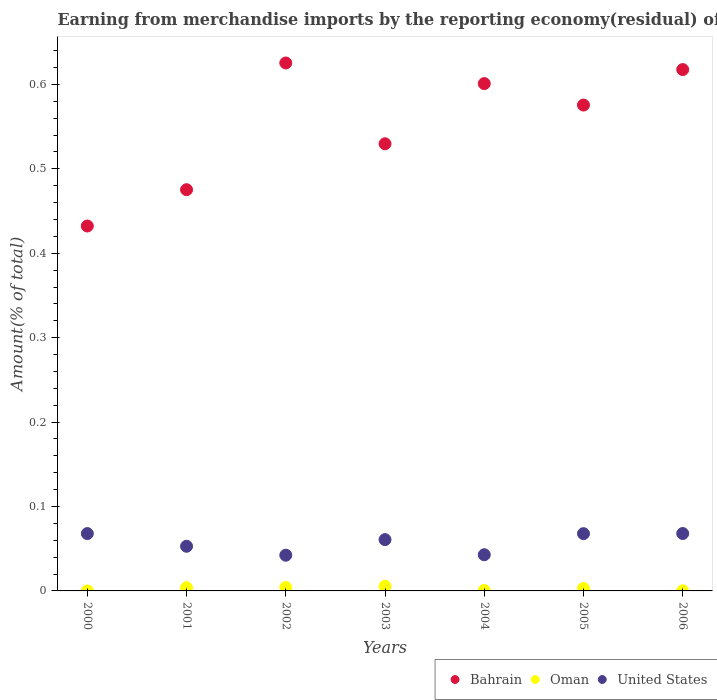How many different coloured dotlines are there?
Make the answer very short. 3. What is the percentage of amount earned from merchandise imports in Bahrain in 2004?
Offer a very short reply. 0.6. Across all years, what is the maximum percentage of amount earned from merchandise imports in United States?
Make the answer very short. 0.07. Across all years, what is the minimum percentage of amount earned from merchandise imports in United States?
Your response must be concise. 0.04. What is the total percentage of amount earned from merchandise imports in United States in the graph?
Your response must be concise. 0.4. What is the difference between the percentage of amount earned from merchandise imports in Bahrain in 2002 and that in 2004?
Give a very brief answer. 0.02. What is the difference between the percentage of amount earned from merchandise imports in Bahrain in 2004 and the percentage of amount earned from merchandise imports in Oman in 2003?
Your answer should be compact. 0.6. What is the average percentage of amount earned from merchandise imports in Oman per year?
Your answer should be compact. 0. In the year 2002, what is the difference between the percentage of amount earned from merchandise imports in Bahrain and percentage of amount earned from merchandise imports in Oman?
Your response must be concise. 0.62. What is the ratio of the percentage of amount earned from merchandise imports in Bahrain in 2003 to that in 2005?
Ensure brevity in your answer.  0.92. Is the difference between the percentage of amount earned from merchandise imports in Bahrain in 2002 and 2006 greater than the difference between the percentage of amount earned from merchandise imports in Oman in 2002 and 2006?
Your response must be concise. Yes. What is the difference between the highest and the second highest percentage of amount earned from merchandise imports in United States?
Your answer should be compact. 6.915576436429538e-5. What is the difference between the highest and the lowest percentage of amount earned from merchandise imports in Oman?
Your answer should be very brief. 0.01. Is the percentage of amount earned from merchandise imports in Oman strictly greater than the percentage of amount earned from merchandise imports in Bahrain over the years?
Your response must be concise. No. Is the percentage of amount earned from merchandise imports in United States strictly less than the percentage of amount earned from merchandise imports in Bahrain over the years?
Ensure brevity in your answer.  Yes. How many dotlines are there?
Your response must be concise. 3. How many years are there in the graph?
Your response must be concise. 7. What is the difference between two consecutive major ticks on the Y-axis?
Offer a very short reply. 0.1. Are the values on the major ticks of Y-axis written in scientific E-notation?
Provide a succinct answer. No. How many legend labels are there?
Your response must be concise. 3. What is the title of the graph?
Ensure brevity in your answer.  Earning from merchandise imports by the reporting economy(residual) of countries. What is the label or title of the Y-axis?
Your answer should be compact. Amount(% of total). What is the Amount(% of total) in Bahrain in 2000?
Make the answer very short. 0.43. What is the Amount(% of total) of United States in 2000?
Keep it short and to the point. 0.07. What is the Amount(% of total) in Bahrain in 2001?
Make the answer very short. 0.48. What is the Amount(% of total) in Oman in 2001?
Provide a short and direct response. 0. What is the Amount(% of total) in United States in 2001?
Your answer should be very brief. 0.05. What is the Amount(% of total) in Bahrain in 2002?
Make the answer very short. 0.63. What is the Amount(% of total) of Oman in 2002?
Offer a very short reply. 0. What is the Amount(% of total) in United States in 2002?
Make the answer very short. 0.04. What is the Amount(% of total) of Bahrain in 2003?
Your answer should be compact. 0.53. What is the Amount(% of total) of Oman in 2003?
Offer a terse response. 0.01. What is the Amount(% of total) of United States in 2003?
Give a very brief answer. 0.06. What is the Amount(% of total) of Bahrain in 2004?
Your response must be concise. 0.6. What is the Amount(% of total) in Oman in 2004?
Offer a very short reply. 0. What is the Amount(% of total) in United States in 2004?
Your answer should be compact. 0.04. What is the Amount(% of total) of Bahrain in 2005?
Provide a succinct answer. 0.58. What is the Amount(% of total) of Oman in 2005?
Your answer should be compact. 0. What is the Amount(% of total) in United States in 2005?
Keep it short and to the point. 0.07. What is the Amount(% of total) in Bahrain in 2006?
Make the answer very short. 0.62. What is the Amount(% of total) of Oman in 2006?
Offer a terse response. 0. What is the Amount(% of total) in United States in 2006?
Offer a terse response. 0.07. Across all years, what is the maximum Amount(% of total) in Bahrain?
Keep it short and to the point. 0.63. Across all years, what is the maximum Amount(% of total) of Oman?
Offer a terse response. 0.01. Across all years, what is the maximum Amount(% of total) of United States?
Give a very brief answer. 0.07. Across all years, what is the minimum Amount(% of total) in Bahrain?
Give a very brief answer. 0.43. Across all years, what is the minimum Amount(% of total) of Oman?
Offer a terse response. 0. Across all years, what is the minimum Amount(% of total) of United States?
Keep it short and to the point. 0.04. What is the total Amount(% of total) in Bahrain in the graph?
Offer a terse response. 3.86. What is the total Amount(% of total) in Oman in the graph?
Your answer should be very brief. 0.02. What is the total Amount(% of total) of United States in the graph?
Provide a succinct answer. 0.4. What is the difference between the Amount(% of total) in Bahrain in 2000 and that in 2001?
Your answer should be compact. -0.04. What is the difference between the Amount(% of total) of United States in 2000 and that in 2001?
Your answer should be compact. 0.01. What is the difference between the Amount(% of total) in Bahrain in 2000 and that in 2002?
Offer a very short reply. -0.19. What is the difference between the Amount(% of total) of United States in 2000 and that in 2002?
Give a very brief answer. 0.03. What is the difference between the Amount(% of total) in Bahrain in 2000 and that in 2003?
Provide a succinct answer. -0.1. What is the difference between the Amount(% of total) in United States in 2000 and that in 2003?
Offer a very short reply. 0.01. What is the difference between the Amount(% of total) of Bahrain in 2000 and that in 2004?
Your answer should be very brief. -0.17. What is the difference between the Amount(% of total) in United States in 2000 and that in 2004?
Make the answer very short. 0.03. What is the difference between the Amount(% of total) in Bahrain in 2000 and that in 2005?
Give a very brief answer. -0.14. What is the difference between the Amount(% of total) in United States in 2000 and that in 2005?
Offer a very short reply. 0. What is the difference between the Amount(% of total) of Bahrain in 2000 and that in 2006?
Make the answer very short. -0.19. What is the difference between the Amount(% of total) in United States in 2000 and that in 2006?
Offer a very short reply. -0. What is the difference between the Amount(% of total) of Bahrain in 2001 and that in 2002?
Give a very brief answer. -0.15. What is the difference between the Amount(% of total) of Oman in 2001 and that in 2002?
Offer a very short reply. -0. What is the difference between the Amount(% of total) in United States in 2001 and that in 2002?
Your answer should be compact. 0.01. What is the difference between the Amount(% of total) of Bahrain in 2001 and that in 2003?
Provide a short and direct response. -0.05. What is the difference between the Amount(% of total) of Oman in 2001 and that in 2003?
Provide a short and direct response. -0. What is the difference between the Amount(% of total) in United States in 2001 and that in 2003?
Ensure brevity in your answer.  -0.01. What is the difference between the Amount(% of total) in Bahrain in 2001 and that in 2004?
Give a very brief answer. -0.13. What is the difference between the Amount(% of total) in Oman in 2001 and that in 2004?
Provide a succinct answer. 0. What is the difference between the Amount(% of total) in Bahrain in 2001 and that in 2005?
Keep it short and to the point. -0.1. What is the difference between the Amount(% of total) in Oman in 2001 and that in 2005?
Give a very brief answer. 0. What is the difference between the Amount(% of total) in United States in 2001 and that in 2005?
Offer a very short reply. -0.01. What is the difference between the Amount(% of total) in Bahrain in 2001 and that in 2006?
Provide a short and direct response. -0.14. What is the difference between the Amount(% of total) of Oman in 2001 and that in 2006?
Provide a succinct answer. 0. What is the difference between the Amount(% of total) in United States in 2001 and that in 2006?
Your answer should be very brief. -0.02. What is the difference between the Amount(% of total) of Bahrain in 2002 and that in 2003?
Offer a very short reply. 0.1. What is the difference between the Amount(% of total) of Oman in 2002 and that in 2003?
Your answer should be very brief. -0. What is the difference between the Amount(% of total) in United States in 2002 and that in 2003?
Give a very brief answer. -0.02. What is the difference between the Amount(% of total) in Bahrain in 2002 and that in 2004?
Your answer should be very brief. 0.02. What is the difference between the Amount(% of total) in Oman in 2002 and that in 2004?
Offer a terse response. 0. What is the difference between the Amount(% of total) of United States in 2002 and that in 2004?
Offer a terse response. -0. What is the difference between the Amount(% of total) in Bahrain in 2002 and that in 2005?
Offer a very short reply. 0.05. What is the difference between the Amount(% of total) in Oman in 2002 and that in 2005?
Your response must be concise. 0. What is the difference between the Amount(% of total) in United States in 2002 and that in 2005?
Your answer should be very brief. -0.03. What is the difference between the Amount(% of total) in Bahrain in 2002 and that in 2006?
Ensure brevity in your answer.  0.01. What is the difference between the Amount(% of total) of Oman in 2002 and that in 2006?
Provide a succinct answer. 0. What is the difference between the Amount(% of total) of United States in 2002 and that in 2006?
Provide a short and direct response. -0.03. What is the difference between the Amount(% of total) of Bahrain in 2003 and that in 2004?
Ensure brevity in your answer.  -0.07. What is the difference between the Amount(% of total) of Oman in 2003 and that in 2004?
Offer a terse response. 0.01. What is the difference between the Amount(% of total) of United States in 2003 and that in 2004?
Your answer should be very brief. 0.02. What is the difference between the Amount(% of total) in Bahrain in 2003 and that in 2005?
Offer a very short reply. -0.05. What is the difference between the Amount(% of total) of Oman in 2003 and that in 2005?
Make the answer very short. 0. What is the difference between the Amount(% of total) in United States in 2003 and that in 2005?
Provide a succinct answer. -0.01. What is the difference between the Amount(% of total) in Bahrain in 2003 and that in 2006?
Provide a short and direct response. -0.09. What is the difference between the Amount(% of total) of Oman in 2003 and that in 2006?
Provide a short and direct response. 0.01. What is the difference between the Amount(% of total) of United States in 2003 and that in 2006?
Your answer should be compact. -0.01. What is the difference between the Amount(% of total) in Bahrain in 2004 and that in 2005?
Your response must be concise. 0.03. What is the difference between the Amount(% of total) of Oman in 2004 and that in 2005?
Offer a terse response. -0. What is the difference between the Amount(% of total) of United States in 2004 and that in 2005?
Your answer should be very brief. -0.03. What is the difference between the Amount(% of total) of Bahrain in 2004 and that in 2006?
Your response must be concise. -0.02. What is the difference between the Amount(% of total) in United States in 2004 and that in 2006?
Your response must be concise. -0.03. What is the difference between the Amount(% of total) of Bahrain in 2005 and that in 2006?
Keep it short and to the point. -0.04. What is the difference between the Amount(% of total) in Oman in 2005 and that in 2006?
Your response must be concise. 0. What is the difference between the Amount(% of total) of United States in 2005 and that in 2006?
Offer a very short reply. -0. What is the difference between the Amount(% of total) in Bahrain in 2000 and the Amount(% of total) in Oman in 2001?
Make the answer very short. 0.43. What is the difference between the Amount(% of total) of Bahrain in 2000 and the Amount(% of total) of United States in 2001?
Provide a short and direct response. 0.38. What is the difference between the Amount(% of total) of Bahrain in 2000 and the Amount(% of total) of Oman in 2002?
Your response must be concise. 0.43. What is the difference between the Amount(% of total) in Bahrain in 2000 and the Amount(% of total) in United States in 2002?
Offer a very short reply. 0.39. What is the difference between the Amount(% of total) of Bahrain in 2000 and the Amount(% of total) of Oman in 2003?
Your answer should be very brief. 0.43. What is the difference between the Amount(% of total) of Bahrain in 2000 and the Amount(% of total) of United States in 2003?
Your response must be concise. 0.37. What is the difference between the Amount(% of total) of Bahrain in 2000 and the Amount(% of total) of Oman in 2004?
Keep it short and to the point. 0.43. What is the difference between the Amount(% of total) in Bahrain in 2000 and the Amount(% of total) in United States in 2004?
Your answer should be compact. 0.39. What is the difference between the Amount(% of total) of Bahrain in 2000 and the Amount(% of total) of Oman in 2005?
Provide a succinct answer. 0.43. What is the difference between the Amount(% of total) in Bahrain in 2000 and the Amount(% of total) in United States in 2005?
Your answer should be compact. 0.36. What is the difference between the Amount(% of total) of Bahrain in 2000 and the Amount(% of total) of Oman in 2006?
Provide a short and direct response. 0.43. What is the difference between the Amount(% of total) of Bahrain in 2000 and the Amount(% of total) of United States in 2006?
Ensure brevity in your answer.  0.36. What is the difference between the Amount(% of total) in Bahrain in 2001 and the Amount(% of total) in Oman in 2002?
Ensure brevity in your answer.  0.47. What is the difference between the Amount(% of total) in Bahrain in 2001 and the Amount(% of total) in United States in 2002?
Provide a short and direct response. 0.43. What is the difference between the Amount(% of total) in Oman in 2001 and the Amount(% of total) in United States in 2002?
Give a very brief answer. -0.04. What is the difference between the Amount(% of total) in Bahrain in 2001 and the Amount(% of total) in Oman in 2003?
Provide a short and direct response. 0.47. What is the difference between the Amount(% of total) of Bahrain in 2001 and the Amount(% of total) of United States in 2003?
Keep it short and to the point. 0.41. What is the difference between the Amount(% of total) in Oman in 2001 and the Amount(% of total) in United States in 2003?
Your answer should be very brief. -0.06. What is the difference between the Amount(% of total) of Bahrain in 2001 and the Amount(% of total) of Oman in 2004?
Your response must be concise. 0.47. What is the difference between the Amount(% of total) of Bahrain in 2001 and the Amount(% of total) of United States in 2004?
Offer a very short reply. 0.43. What is the difference between the Amount(% of total) in Oman in 2001 and the Amount(% of total) in United States in 2004?
Offer a terse response. -0.04. What is the difference between the Amount(% of total) of Bahrain in 2001 and the Amount(% of total) of Oman in 2005?
Your response must be concise. 0.47. What is the difference between the Amount(% of total) of Bahrain in 2001 and the Amount(% of total) of United States in 2005?
Ensure brevity in your answer.  0.41. What is the difference between the Amount(% of total) in Oman in 2001 and the Amount(% of total) in United States in 2005?
Your response must be concise. -0.06. What is the difference between the Amount(% of total) of Bahrain in 2001 and the Amount(% of total) of Oman in 2006?
Your answer should be compact. 0.48. What is the difference between the Amount(% of total) in Bahrain in 2001 and the Amount(% of total) in United States in 2006?
Your answer should be compact. 0.41. What is the difference between the Amount(% of total) in Oman in 2001 and the Amount(% of total) in United States in 2006?
Provide a succinct answer. -0.06. What is the difference between the Amount(% of total) of Bahrain in 2002 and the Amount(% of total) of Oman in 2003?
Offer a very short reply. 0.62. What is the difference between the Amount(% of total) of Bahrain in 2002 and the Amount(% of total) of United States in 2003?
Your answer should be compact. 0.56. What is the difference between the Amount(% of total) of Oman in 2002 and the Amount(% of total) of United States in 2003?
Give a very brief answer. -0.06. What is the difference between the Amount(% of total) in Bahrain in 2002 and the Amount(% of total) in Oman in 2004?
Ensure brevity in your answer.  0.62. What is the difference between the Amount(% of total) of Bahrain in 2002 and the Amount(% of total) of United States in 2004?
Your response must be concise. 0.58. What is the difference between the Amount(% of total) of Oman in 2002 and the Amount(% of total) of United States in 2004?
Keep it short and to the point. -0.04. What is the difference between the Amount(% of total) of Bahrain in 2002 and the Amount(% of total) of Oman in 2005?
Give a very brief answer. 0.62. What is the difference between the Amount(% of total) in Bahrain in 2002 and the Amount(% of total) in United States in 2005?
Your response must be concise. 0.56. What is the difference between the Amount(% of total) of Oman in 2002 and the Amount(% of total) of United States in 2005?
Your response must be concise. -0.06. What is the difference between the Amount(% of total) of Bahrain in 2002 and the Amount(% of total) of Oman in 2006?
Ensure brevity in your answer.  0.63. What is the difference between the Amount(% of total) of Bahrain in 2002 and the Amount(% of total) of United States in 2006?
Your response must be concise. 0.56. What is the difference between the Amount(% of total) in Oman in 2002 and the Amount(% of total) in United States in 2006?
Offer a very short reply. -0.06. What is the difference between the Amount(% of total) in Bahrain in 2003 and the Amount(% of total) in Oman in 2004?
Your response must be concise. 0.53. What is the difference between the Amount(% of total) of Bahrain in 2003 and the Amount(% of total) of United States in 2004?
Provide a short and direct response. 0.49. What is the difference between the Amount(% of total) of Oman in 2003 and the Amount(% of total) of United States in 2004?
Keep it short and to the point. -0.04. What is the difference between the Amount(% of total) in Bahrain in 2003 and the Amount(% of total) in Oman in 2005?
Give a very brief answer. 0.53. What is the difference between the Amount(% of total) of Bahrain in 2003 and the Amount(% of total) of United States in 2005?
Your response must be concise. 0.46. What is the difference between the Amount(% of total) of Oman in 2003 and the Amount(% of total) of United States in 2005?
Give a very brief answer. -0.06. What is the difference between the Amount(% of total) of Bahrain in 2003 and the Amount(% of total) of Oman in 2006?
Make the answer very short. 0.53. What is the difference between the Amount(% of total) of Bahrain in 2003 and the Amount(% of total) of United States in 2006?
Offer a terse response. 0.46. What is the difference between the Amount(% of total) in Oman in 2003 and the Amount(% of total) in United States in 2006?
Your answer should be compact. -0.06. What is the difference between the Amount(% of total) in Bahrain in 2004 and the Amount(% of total) in Oman in 2005?
Your answer should be very brief. 0.6. What is the difference between the Amount(% of total) in Bahrain in 2004 and the Amount(% of total) in United States in 2005?
Provide a short and direct response. 0.53. What is the difference between the Amount(% of total) in Oman in 2004 and the Amount(% of total) in United States in 2005?
Your answer should be compact. -0.07. What is the difference between the Amount(% of total) of Bahrain in 2004 and the Amount(% of total) of Oman in 2006?
Make the answer very short. 0.6. What is the difference between the Amount(% of total) in Bahrain in 2004 and the Amount(% of total) in United States in 2006?
Offer a very short reply. 0.53. What is the difference between the Amount(% of total) in Oman in 2004 and the Amount(% of total) in United States in 2006?
Your answer should be compact. -0.07. What is the difference between the Amount(% of total) of Bahrain in 2005 and the Amount(% of total) of Oman in 2006?
Ensure brevity in your answer.  0.58. What is the difference between the Amount(% of total) in Bahrain in 2005 and the Amount(% of total) in United States in 2006?
Keep it short and to the point. 0.51. What is the difference between the Amount(% of total) of Oman in 2005 and the Amount(% of total) of United States in 2006?
Offer a very short reply. -0.07. What is the average Amount(% of total) of Bahrain per year?
Give a very brief answer. 0.55. What is the average Amount(% of total) in Oman per year?
Provide a succinct answer. 0. What is the average Amount(% of total) in United States per year?
Provide a short and direct response. 0.06. In the year 2000, what is the difference between the Amount(% of total) in Bahrain and Amount(% of total) in United States?
Keep it short and to the point. 0.36. In the year 2001, what is the difference between the Amount(% of total) of Bahrain and Amount(% of total) of Oman?
Provide a short and direct response. 0.47. In the year 2001, what is the difference between the Amount(% of total) in Bahrain and Amount(% of total) in United States?
Provide a short and direct response. 0.42. In the year 2001, what is the difference between the Amount(% of total) of Oman and Amount(% of total) of United States?
Ensure brevity in your answer.  -0.05. In the year 2002, what is the difference between the Amount(% of total) of Bahrain and Amount(% of total) of Oman?
Keep it short and to the point. 0.62. In the year 2002, what is the difference between the Amount(% of total) in Bahrain and Amount(% of total) in United States?
Provide a short and direct response. 0.58. In the year 2002, what is the difference between the Amount(% of total) of Oman and Amount(% of total) of United States?
Ensure brevity in your answer.  -0.04. In the year 2003, what is the difference between the Amount(% of total) of Bahrain and Amount(% of total) of Oman?
Give a very brief answer. 0.52. In the year 2003, what is the difference between the Amount(% of total) in Bahrain and Amount(% of total) in United States?
Your answer should be very brief. 0.47. In the year 2003, what is the difference between the Amount(% of total) in Oman and Amount(% of total) in United States?
Provide a succinct answer. -0.06. In the year 2004, what is the difference between the Amount(% of total) in Bahrain and Amount(% of total) in Oman?
Provide a short and direct response. 0.6. In the year 2004, what is the difference between the Amount(% of total) of Bahrain and Amount(% of total) of United States?
Give a very brief answer. 0.56. In the year 2004, what is the difference between the Amount(% of total) of Oman and Amount(% of total) of United States?
Offer a very short reply. -0.04. In the year 2005, what is the difference between the Amount(% of total) of Bahrain and Amount(% of total) of Oman?
Your response must be concise. 0.57. In the year 2005, what is the difference between the Amount(% of total) of Bahrain and Amount(% of total) of United States?
Your answer should be compact. 0.51. In the year 2005, what is the difference between the Amount(% of total) in Oman and Amount(% of total) in United States?
Offer a very short reply. -0.06. In the year 2006, what is the difference between the Amount(% of total) of Bahrain and Amount(% of total) of Oman?
Ensure brevity in your answer.  0.62. In the year 2006, what is the difference between the Amount(% of total) of Bahrain and Amount(% of total) of United States?
Your response must be concise. 0.55. In the year 2006, what is the difference between the Amount(% of total) of Oman and Amount(% of total) of United States?
Your response must be concise. -0.07. What is the ratio of the Amount(% of total) in Bahrain in 2000 to that in 2001?
Your response must be concise. 0.91. What is the ratio of the Amount(% of total) in United States in 2000 to that in 2001?
Your response must be concise. 1.28. What is the ratio of the Amount(% of total) of Bahrain in 2000 to that in 2002?
Give a very brief answer. 0.69. What is the ratio of the Amount(% of total) in United States in 2000 to that in 2002?
Keep it short and to the point. 1.61. What is the ratio of the Amount(% of total) of Bahrain in 2000 to that in 2003?
Offer a terse response. 0.82. What is the ratio of the Amount(% of total) in United States in 2000 to that in 2003?
Offer a terse response. 1.12. What is the ratio of the Amount(% of total) in Bahrain in 2000 to that in 2004?
Your response must be concise. 0.72. What is the ratio of the Amount(% of total) of United States in 2000 to that in 2004?
Offer a very short reply. 1.58. What is the ratio of the Amount(% of total) of Bahrain in 2000 to that in 2005?
Your answer should be very brief. 0.75. What is the ratio of the Amount(% of total) of United States in 2000 to that in 2005?
Your answer should be compact. 1. What is the ratio of the Amount(% of total) in Bahrain in 2000 to that in 2006?
Your response must be concise. 0.7. What is the ratio of the Amount(% of total) of Bahrain in 2001 to that in 2002?
Offer a very short reply. 0.76. What is the ratio of the Amount(% of total) in Oman in 2001 to that in 2002?
Make the answer very short. 0.93. What is the ratio of the Amount(% of total) in United States in 2001 to that in 2002?
Make the answer very short. 1.25. What is the ratio of the Amount(% of total) of Bahrain in 2001 to that in 2003?
Provide a succinct answer. 0.9. What is the ratio of the Amount(% of total) in Oman in 2001 to that in 2003?
Your response must be concise. 0.69. What is the ratio of the Amount(% of total) of United States in 2001 to that in 2003?
Provide a succinct answer. 0.87. What is the ratio of the Amount(% of total) in Bahrain in 2001 to that in 2004?
Your answer should be compact. 0.79. What is the ratio of the Amount(% of total) in Oman in 2001 to that in 2004?
Your response must be concise. 6.5. What is the ratio of the Amount(% of total) in United States in 2001 to that in 2004?
Provide a short and direct response. 1.23. What is the ratio of the Amount(% of total) of Bahrain in 2001 to that in 2005?
Offer a very short reply. 0.83. What is the ratio of the Amount(% of total) of Oman in 2001 to that in 2005?
Provide a succinct answer. 1.31. What is the ratio of the Amount(% of total) of United States in 2001 to that in 2005?
Give a very brief answer. 0.78. What is the ratio of the Amount(% of total) in Bahrain in 2001 to that in 2006?
Ensure brevity in your answer.  0.77. What is the ratio of the Amount(% of total) in Oman in 2001 to that in 2006?
Keep it short and to the point. 30.31. What is the ratio of the Amount(% of total) of United States in 2001 to that in 2006?
Provide a short and direct response. 0.78. What is the ratio of the Amount(% of total) in Bahrain in 2002 to that in 2003?
Give a very brief answer. 1.18. What is the ratio of the Amount(% of total) in Oman in 2002 to that in 2003?
Your answer should be compact. 0.74. What is the ratio of the Amount(% of total) of United States in 2002 to that in 2003?
Offer a terse response. 0.7. What is the ratio of the Amount(% of total) in Bahrain in 2002 to that in 2004?
Keep it short and to the point. 1.04. What is the ratio of the Amount(% of total) in Oman in 2002 to that in 2004?
Your answer should be very brief. 6.98. What is the ratio of the Amount(% of total) in United States in 2002 to that in 2004?
Provide a short and direct response. 0.99. What is the ratio of the Amount(% of total) in Bahrain in 2002 to that in 2005?
Ensure brevity in your answer.  1.09. What is the ratio of the Amount(% of total) of Oman in 2002 to that in 2005?
Give a very brief answer. 1.41. What is the ratio of the Amount(% of total) in United States in 2002 to that in 2005?
Provide a short and direct response. 0.62. What is the ratio of the Amount(% of total) of Bahrain in 2002 to that in 2006?
Ensure brevity in your answer.  1.01. What is the ratio of the Amount(% of total) of Oman in 2002 to that in 2006?
Your answer should be very brief. 32.52. What is the ratio of the Amount(% of total) of United States in 2002 to that in 2006?
Provide a short and direct response. 0.62. What is the ratio of the Amount(% of total) in Bahrain in 2003 to that in 2004?
Offer a terse response. 0.88. What is the ratio of the Amount(% of total) of Oman in 2003 to that in 2004?
Your answer should be very brief. 9.45. What is the ratio of the Amount(% of total) of United States in 2003 to that in 2004?
Ensure brevity in your answer.  1.42. What is the ratio of the Amount(% of total) of Bahrain in 2003 to that in 2005?
Provide a succinct answer. 0.92. What is the ratio of the Amount(% of total) in Oman in 2003 to that in 2005?
Give a very brief answer. 1.91. What is the ratio of the Amount(% of total) in United States in 2003 to that in 2005?
Make the answer very short. 0.9. What is the ratio of the Amount(% of total) of Bahrain in 2003 to that in 2006?
Give a very brief answer. 0.86. What is the ratio of the Amount(% of total) in Oman in 2003 to that in 2006?
Offer a terse response. 44.01. What is the ratio of the Amount(% of total) of United States in 2003 to that in 2006?
Offer a very short reply. 0.89. What is the ratio of the Amount(% of total) in Bahrain in 2004 to that in 2005?
Your answer should be compact. 1.04. What is the ratio of the Amount(% of total) in Oman in 2004 to that in 2005?
Offer a very short reply. 0.2. What is the ratio of the Amount(% of total) of United States in 2004 to that in 2005?
Make the answer very short. 0.63. What is the ratio of the Amount(% of total) in Bahrain in 2004 to that in 2006?
Give a very brief answer. 0.97. What is the ratio of the Amount(% of total) in Oman in 2004 to that in 2006?
Offer a terse response. 4.66. What is the ratio of the Amount(% of total) of United States in 2004 to that in 2006?
Offer a terse response. 0.63. What is the ratio of the Amount(% of total) in Bahrain in 2005 to that in 2006?
Provide a succinct answer. 0.93. What is the ratio of the Amount(% of total) in Oman in 2005 to that in 2006?
Offer a very short reply. 23.07. What is the ratio of the Amount(% of total) of United States in 2005 to that in 2006?
Provide a succinct answer. 1. What is the difference between the highest and the second highest Amount(% of total) in Bahrain?
Your response must be concise. 0.01. What is the difference between the highest and the second highest Amount(% of total) of Oman?
Ensure brevity in your answer.  0. What is the difference between the highest and the second highest Amount(% of total) in United States?
Provide a short and direct response. 0. What is the difference between the highest and the lowest Amount(% of total) of Bahrain?
Provide a short and direct response. 0.19. What is the difference between the highest and the lowest Amount(% of total) in Oman?
Ensure brevity in your answer.  0.01. What is the difference between the highest and the lowest Amount(% of total) of United States?
Your answer should be compact. 0.03. 